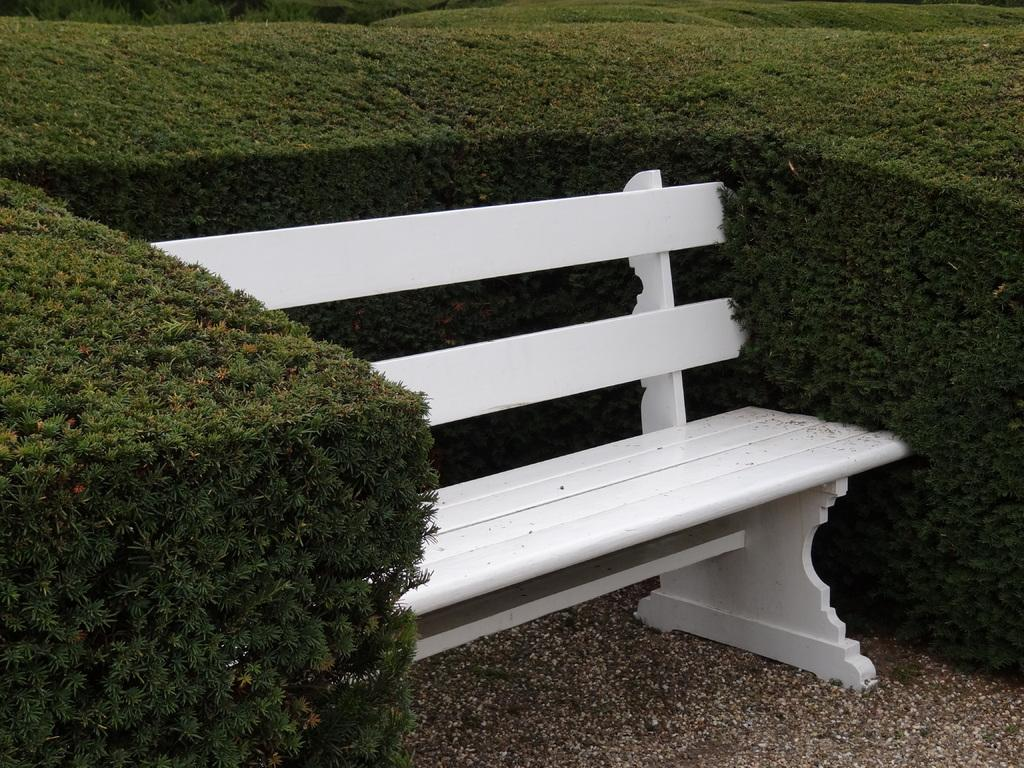What type of seating is present in the image? There is a white-colored bench in the image. Where is the bench located? The bench is on the ground. What can be seen around the bench? There are plants around the bench. What is the color of the plants? The plants are green in color. What type of polish is being applied to the gate in the image? There is no gate present in the image, so it is not possible to determine if any polish is being applied. 